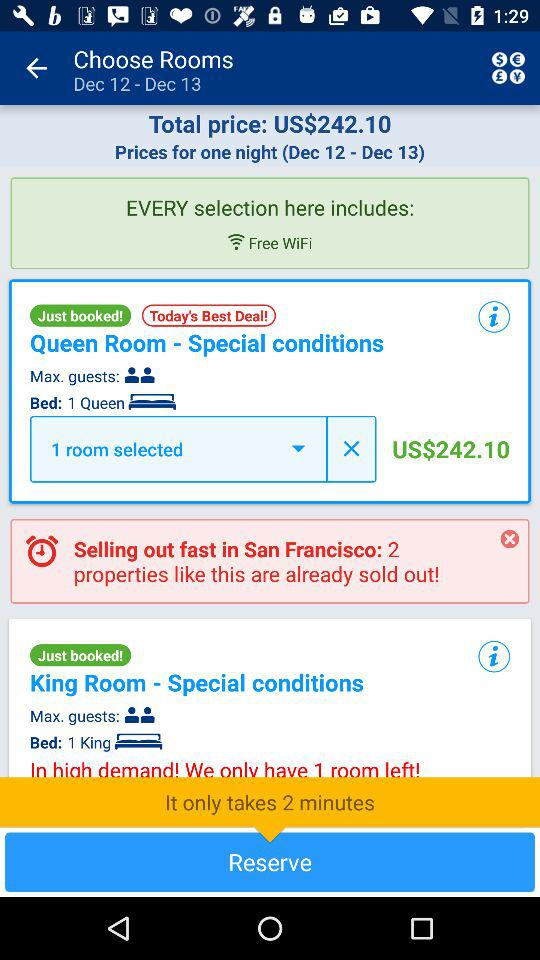How many rooms are selected? There is 1 room selected. 